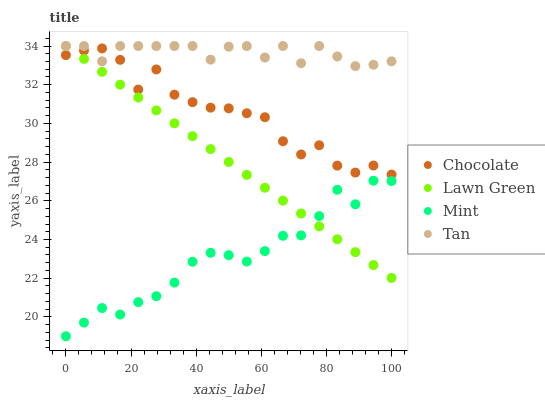Does Mint have the minimum area under the curve?
Answer yes or no. Yes. Does Tan have the maximum area under the curve?
Answer yes or no. Yes. Does Tan have the minimum area under the curve?
Answer yes or no. No. Does Mint have the maximum area under the curve?
Answer yes or no. No. Is Lawn Green the smoothest?
Answer yes or no. Yes. Is Chocolate the roughest?
Answer yes or no. Yes. Is Tan the smoothest?
Answer yes or no. No. Is Tan the roughest?
Answer yes or no. No. Does Mint have the lowest value?
Answer yes or no. Yes. Does Tan have the lowest value?
Answer yes or no. No. Does Tan have the highest value?
Answer yes or no. Yes. Does Mint have the highest value?
Answer yes or no. No. Is Mint less than Tan?
Answer yes or no. Yes. Is Tan greater than Mint?
Answer yes or no. Yes. Does Lawn Green intersect Chocolate?
Answer yes or no. Yes. Is Lawn Green less than Chocolate?
Answer yes or no. No. Is Lawn Green greater than Chocolate?
Answer yes or no. No. Does Mint intersect Tan?
Answer yes or no. No. 